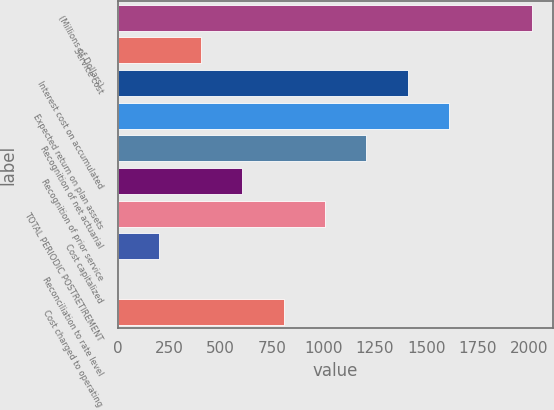<chart> <loc_0><loc_0><loc_500><loc_500><bar_chart><fcel>(Millions of Dollars)<fcel>Service cost<fcel>Interest cost on accumulated<fcel>Expected return on plan assets<fcel>Recognition of net actuarial<fcel>Recognition of prior service<fcel>TOTAL PERIODIC POSTRETIREMENT<fcel>Cost capitalized<fcel>Reconciliation to rate level<fcel>Cost charged to operating<nl><fcel>2014<fcel>404.4<fcel>1410.4<fcel>1611.6<fcel>1209.2<fcel>605.6<fcel>1008<fcel>203.2<fcel>2<fcel>806.8<nl></chart> 